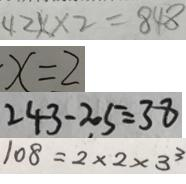<formula> <loc_0><loc_0><loc_500><loc_500>4 2 x \times 2 = 8 4 8 
 x = 2 
 2 4 3 - 2 0 5 = 3 8 
 1 0 8 = 2 \times 2 \times 3 ^ { 3 }</formula> 